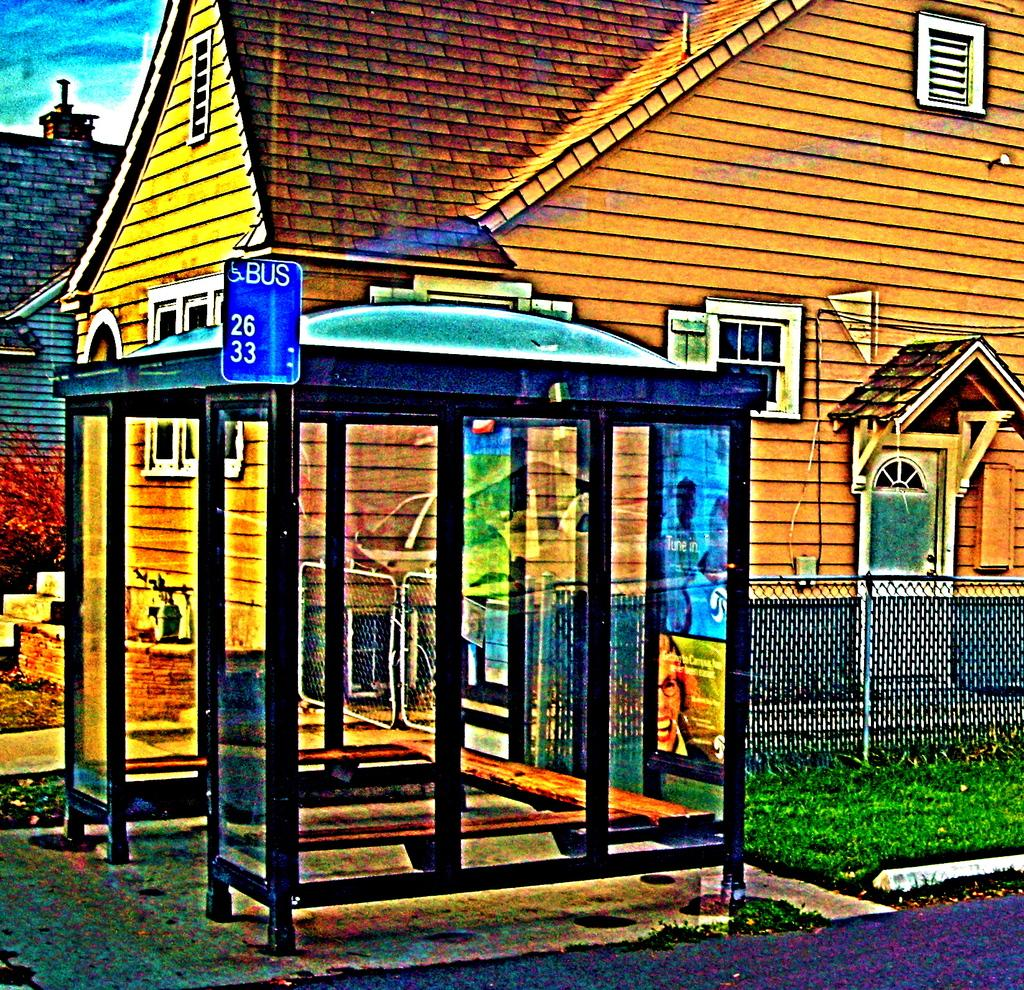What type of structures can be seen in the image? There are buildings in the image. What feature is visible on the buildings? There are windows visible in the image. What object can be seen in the image besides the buildings? There is a board in the image. What is the color of the sky in the background of the image? The sky in the background is blue and white in color. What advice is the cat giving to the linen in the image? There is no cat or linen present in the image, so no advice can be given. 